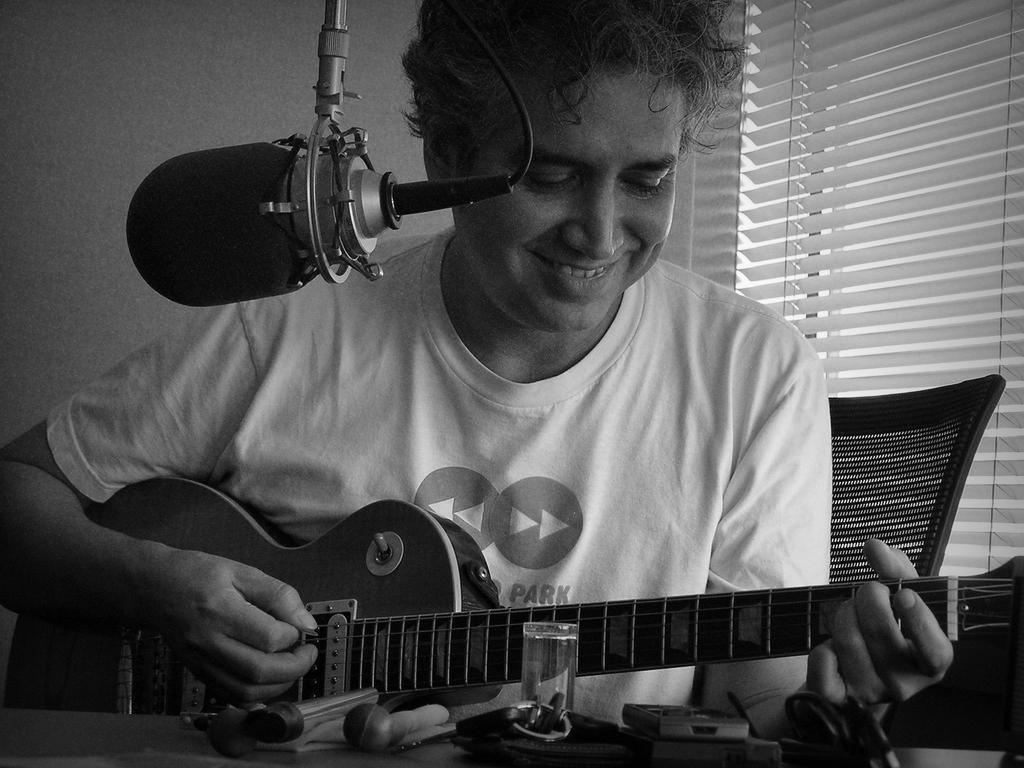Who is the main subject in the image? There is a man in the image. What is the man doing in the image? The man is playing a guitar and smiling. What object is present near the man? There is a microphone in the image. What can be seen in the background of the image? There is a wall and a window in the background of the image. How many passengers are visible in the image? There are no passengers present in the image; it features a man playing a guitar. What type of slope can be seen in the image? There is no slope present in the image. 